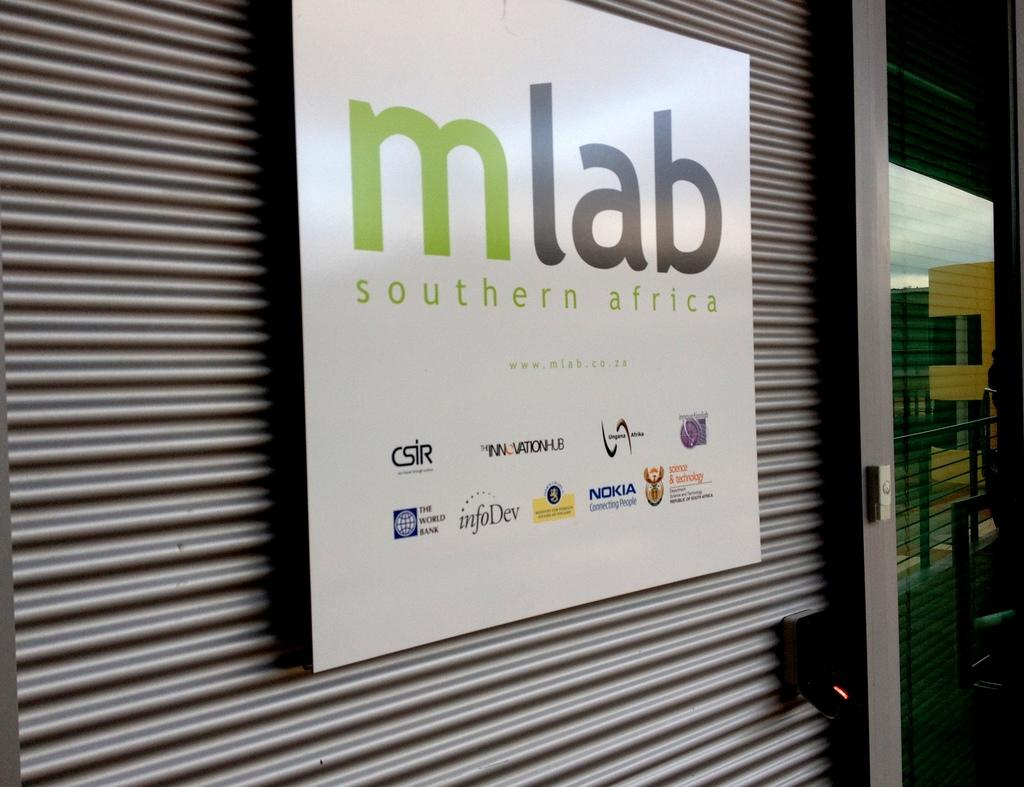What is hanging on the shutter in the image? There is an advertising banner on a shutter in the image. What object in the image has a reflection? There is a glass with a reflection in the image. What can be seen in the reflection of the glass? The reflection includes buildings. How many knots are tied in the advertising banner in the image? There is no mention of knots in the advertising banner in the image, so it is impossible to determine the number of knots. What type of bird can be seen flying in the reflection of the glass? There is no bird visible in the reflection of the glass in the image. 